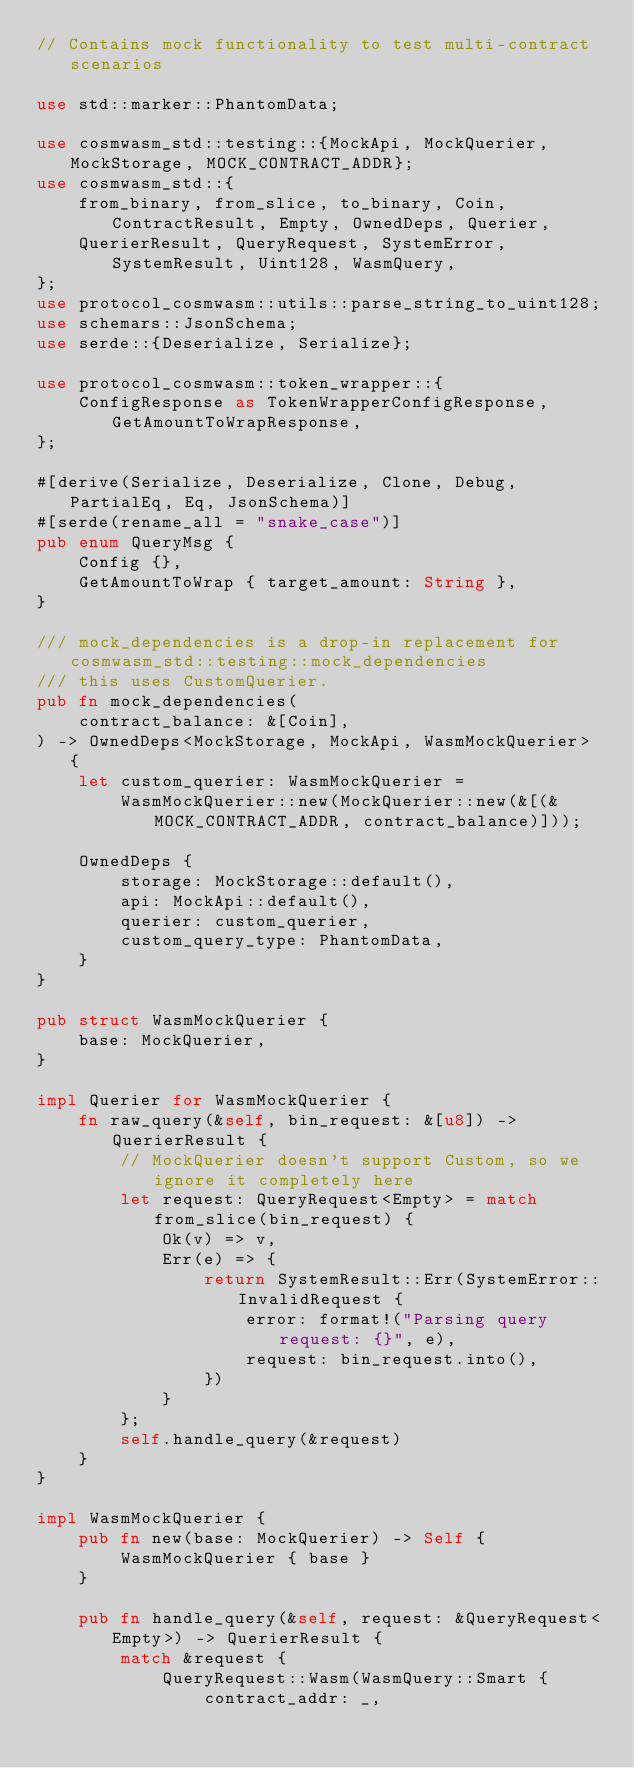Convert code to text. <code><loc_0><loc_0><loc_500><loc_500><_Rust_>// Contains mock functionality to test multi-contract scenarios

use std::marker::PhantomData;

use cosmwasm_std::testing::{MockApi, MockQuerier, MockStorage, MOCK_CONTRACT_ADDR};
use cosmwasm_std::{
    from_binary, from_slice, to_binary, Coin, ContractResult, Empty, OwnedDeps, Querier,
    QuerierResult, QueryRequest, SystemError, SystemResult, Uint128, WasmQuery,
};
use protocol_cosmwasm::utils::parse_string_to_uint128;
use schemars::JsonSchema;
use serde::{Deserialize, Serialize};

use protocol_cosmwasm::token_wrapper::{
    ConfigResponse as TokenWrapperConfigResponse, GetAmountToWrapResponse,
};

#[derive(Serialize, Deserialize, Clone, Debug, PartialEq, Eq, JsonSchema)]
#[serde(rename_all = "snake_case")]
pub enum QueryMsg {
    Config {},
    GetAmountToWrap { target_amount: String },
}

/// mock_dependencies is a drop-in replacement for cosmwasm_std::testing::mock_dependencies
/// this uses CustomQuerier.
pub fn mock_dependencies(
    contract_balance: &[Coin],
) -> OwnedDeps<MockStorage, MockApi, WasmMockQuerier> {
    let custom_querier: WasmMockQuerier =
        WasmMockQuerier::new(MockQuerier::new(&[(&MOCK_CONTRACT_ADDR, contract_balance)]));

    OwnedDeps {
        storage: MockStorage::default(),
        api: MockApi::default(),
        querier: custom_querier,
        custom_query_type: PhantomData,
    }
}

pub struct WasmMockQuerier {
    base: MockQuerier,
}

impl Querier for WasmMockQuerier {
    fn raw_query(&self, bin_request: &[u8]) -> QuerierResult {
        // MockQuerier doesn't support Custom, so we ignore it completely here
        let request: QueryRequest<Empty> = match from_slice(bin_request) {
            Ok(v) => v,
            Err(e) => {
                return SystemResult::Err(SystemError::InvalidRequest {
                    error: format!("Parsing query request: {}", e),
                    request: bin_request.into(),
                })
            }
        };
        self.handle_query(&request)
    }
}

impl WasmMockQuerier {
    pub fn new(base: MockQuerier) -> Self {
        WasmMockQuerier { base }
    }

    pub fn handle_query(&self, request: &QueryRequest<Empty>) -> QuerierResult {
        match &request {
            QueryRequest::Wasm(WasmQuery::Smart {
                contract_addr: _,</code> 